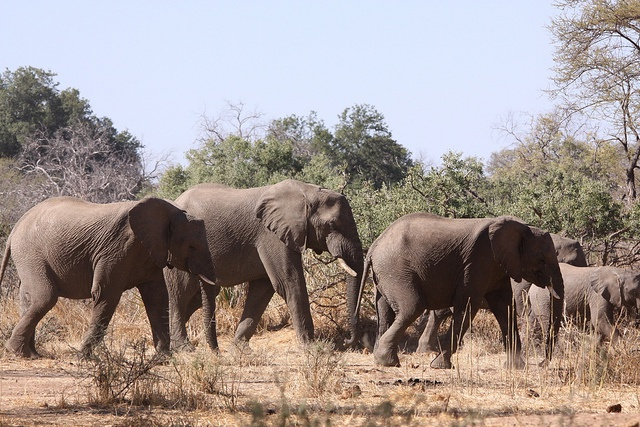Describe the objects in this image and their specific colors. I can see elephant in lavender, black, tan, darkgray, and gray tones, elephant in lavender, black, gray, and darkgray tones, elephant in lavender, black, gray, and darkgray tones, elephant in lavender, darkgray, gray, black, and tan tones, and elephant in lavender, black, gray, and darkgray tones in this image. 